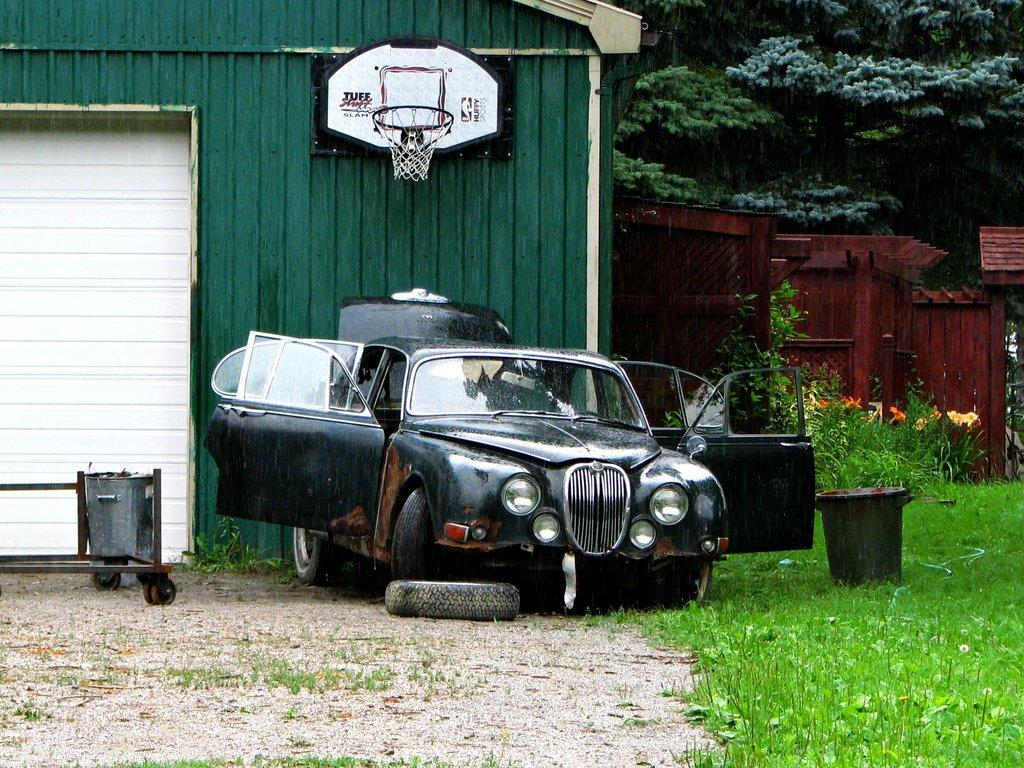Could you give a brief overview of what you see in this image? In this picture we can observe a black color car parked on the land. We can observe a tire and two trash bins here. There is some grass on the ground. We can observe a basketball net fixed to this green color wall. In the background there are trees and plants. 